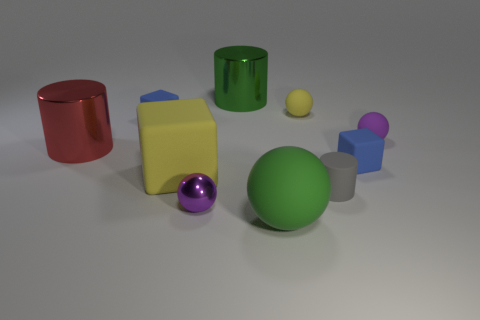Subtract all red cylinders. How many cylinders are left? 2 Subtract all blocks. How many objects are left? 7 Subtract all gray blocks. How many purple balls are left? 2 Subtract all yellow balls. How many balls are left? 3 Subtract all big rubber objects. Subtract all purple things. How many objects are left? 6 Add 5 large green metallic things. How many large green metallic things are left? 6 Add 4 tiny gray rubber blocks. How many tiny gray rubber blocks exist? 4 Subtract 0 red cubes. How many objects are left? 10 Subtract all purple cylinders. Subtract all gray spheres. How many cylinders are left? 3 